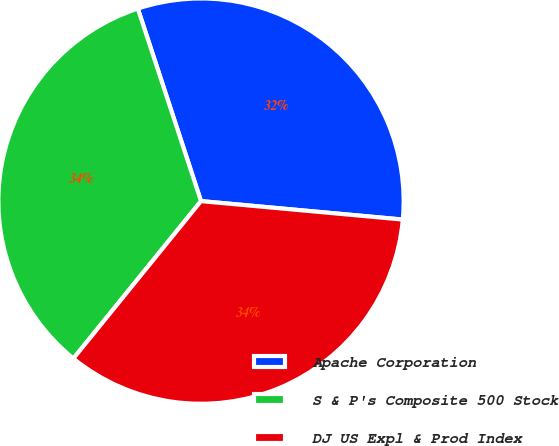Convert chart. <chart><loc_0><loc_0><loc_500><loc_500><pie_chart><fcel>Apache Corporation<fcel>S & P's Composite 500 Stock<fcel>DJ US Expl & Prod Index<nl><fcel>31.5%<fcel>34.11%<fcel>34.39%<nl></chart> 